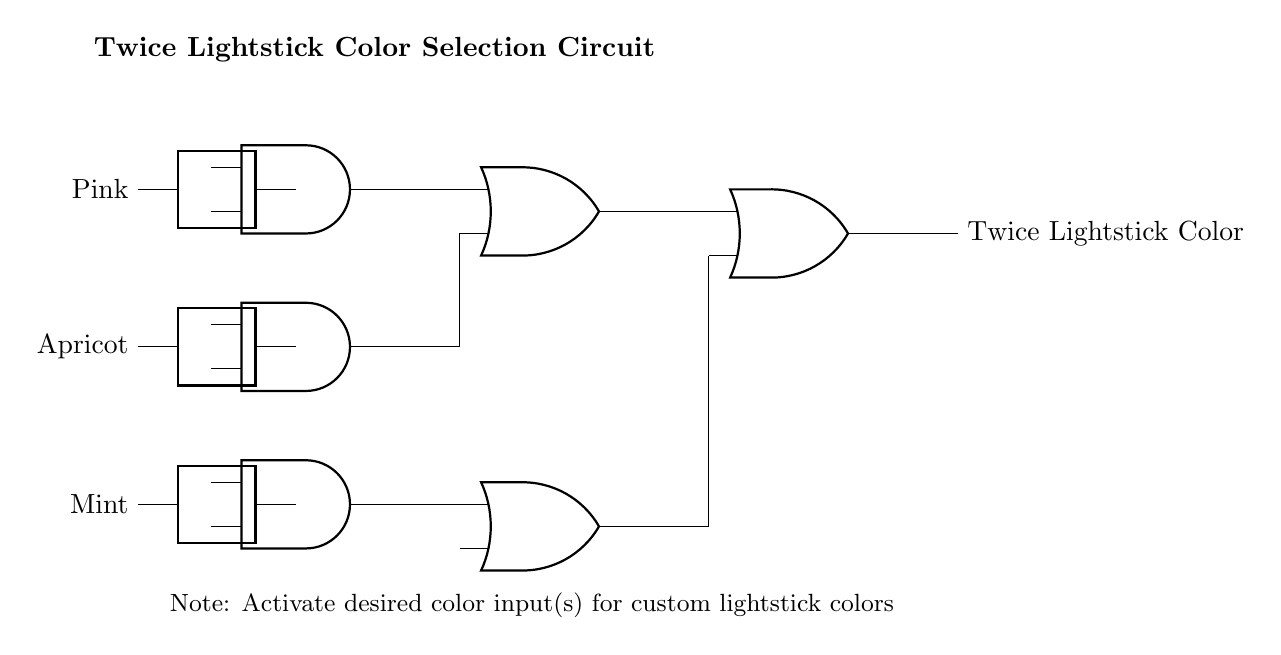What are the three color options available? The circuit indicates three input switches for color selection: Pink, Apricot, and Mint. Therefore, the available colors are directly represented by these switches.
Answer: Pink, Apricot, Mint What type of logic gates are used in this circuit? The circuit diagram shows the use of AND gates for the initial input combinations and OR gates for combining the outputs. This combination is essential for determining the final output color.
Answer: AND and OR How many AND gates are present in the circuit? By analyzing the diagram, there are three AND gates utilized to process the three color inputs separately before the outputs are combined.
Answer: Three What does the final output represent? The final output of the circuit is the Twice Lightstick Color, which is determined based on the selected combinations of the initial color inputs through the logic gates.
Answer: Twice Lightstick Color How many OR gates are in the circuit? The circuit includes three OR gates, which are employed to combine the outputs from the AND gates and the previous OR gates, leading to the final output.
Answer: Three What happens when multiple input switches are activated? Since the logic gates are configured to accept multiple inputs, activating multiple switches will allow the OR gates to combine their outputs, resulting in a custom lightstick color being displayed.
Answer: Custom lightstick color 